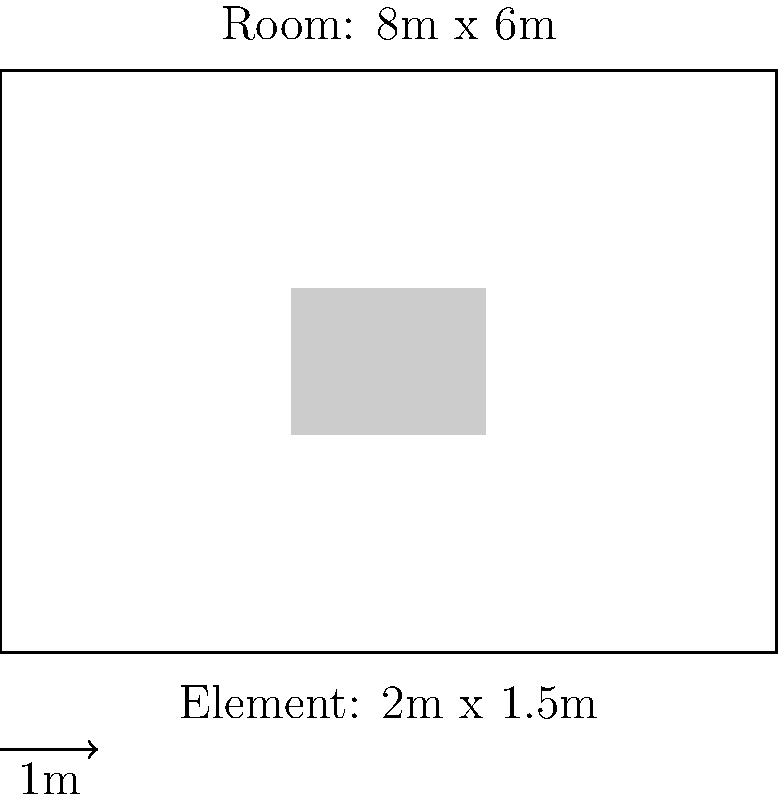In a room measuring 8m x 6m, a decorative element (such as a painting or mirror) is being considered for placement. The element measures 2m x 1.5m. Calculate the percentage of the room's shorter wall that this element would occupy. Is this proportion appropriate according to the general interior design principle of the "rule of thirds"? To determine if the decorative element's scale is appropriate for the room, we'll follow these steps:

1. Identify the shorter wall:
   The room dimensions are 8m x 6m, so the shorter wall is 6m.

2. Calculate the percentage of the shorter wall occupied by the element:
   Element width = 2m
   Shorter wall length = 6m
   Percentage = (Element width / Shorter wall length) * 100
   Percentage = (2m / 6m) * 100 = 33.33%

3. Apply the "rule of thirds":
   The rule of thirds suggests that dividing a space into thirds often creates pleasing proportions. In interior design, this can mean that decorative elements should occupy about 1/3 (33.33%) of the wall space for optimal visual balance.

4. Evaluate the proportion:
   The calculated percentage (33.33%) perfectly aligns with the rule of thirds, suggesting that the scale of the decorative element is appropriate for the room size.

5. Consider additional factors:
   While the proportion is mathematically correct, other factors such as the room's function, existing furniture, and overall design scheme should also be considered for a well-balanced interior.
Answer: 33.33%; appropriate according to the rule of thirds 